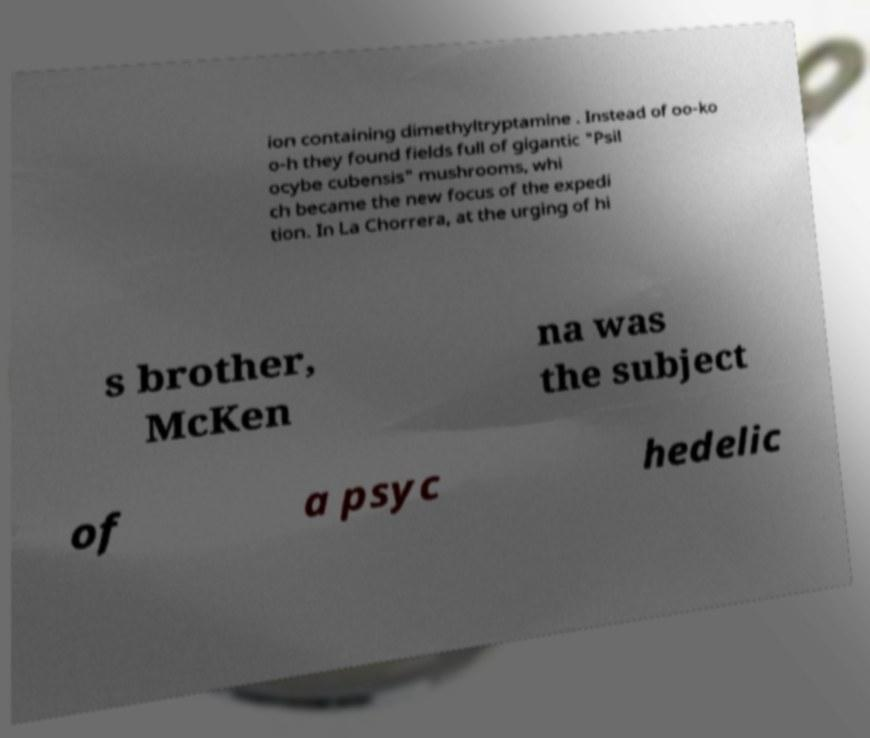What messages or text are displayed in this image? I need them in a readable, typed format. ion containing dimethyltryptamine . Instead of oo-ko o-h they found fields full of gigantic "Psil ocybe cubensis" mushrooms, whi ch became the new focus of the expedi tion. In La Chorrera, at the urging of hi s brother, McKen na was the subject of a psyc hedelic 